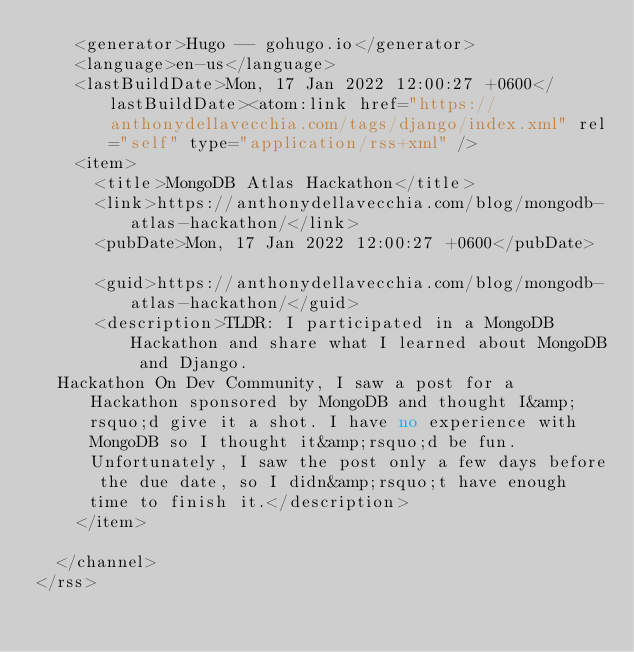Convert code to text. <code><loc_0><loc_0><loc_500><loc_500><_XML_>    <generator>Hugo -- gohugo.io</generator>
    <language>en-us</language>
    <lastBuildDate>Mon, 17 Jan 2022 12:00:27 +0600</lastBuildDate><atom:link href="https://anthonydellavecchia.com/tags/django/index.xml" rel="self" type="application/rss+xml" />
    <item>
      <title>MongoDB Atlas Hackathon</title>
      <link>https://anthonydellavecchia.com/blog/mongodb-atlas-hackathon/</link>
      <pubDate>Mon, 17 Jan 2022 12:00:27 +0600</pubDate>
      
      <guid>https://anthonydellavecchia.com/blog/mongodb-atlas-hackathon/</guid>
      <description>TLDR: I participated in a MongoDB Hackathon and share what I learned about MongoDB and Django.
  Hackathon On Dev Community, I saw a post for a Hackathon sponsored by MongoDB and thought I&amp;rsquo;d give it a shot. I have no experience with MongoDB so I thought it&amp;rsquo;d be fun. Unfortunately, I saw the post only a few days before the due date, so I didn&amp;rsquo;t have enough time to finish it.</description>
    </item>
    
  </channel>
</rss>
</code> 